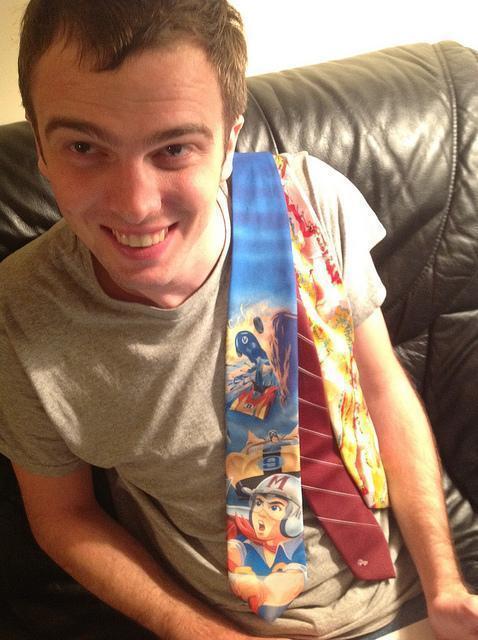What clothing item does the man have most of?
Choose the correct response, then elucidate: 'Answer: answer
Rationale: rationale.'
Options: Ties, jeans, shirts, gloves. Answer: ties.
Rationale: The man has a lot of ties on his shoulder. 